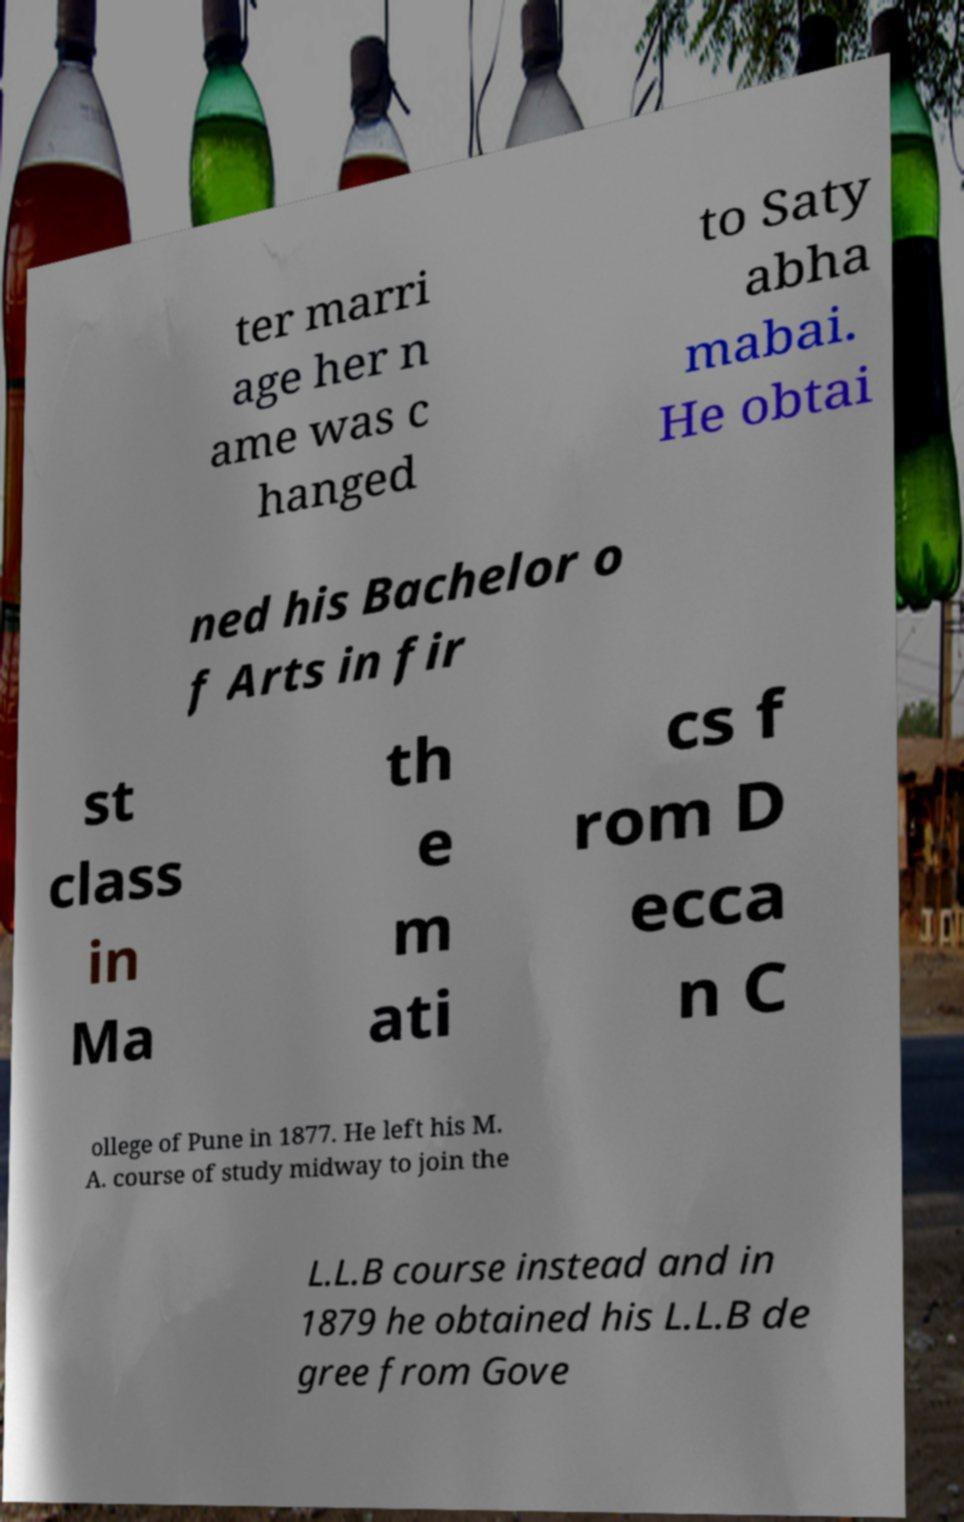Can you read and provide the text displayed in the image?This photo seems to have some interesting text. Can you extract and type it out for me? ter marri age her n ame was c hanged to Saty abha mabai. He obtai ned his Bachelor o f Arts in fir st class in Ma th e m ati cs f rom D ecca n C ollege of Pune in 1877. He left his M. A. course of study midway to join the L.L.B course instead and in 1879 he obtained his L.L.B de gree from Gove 